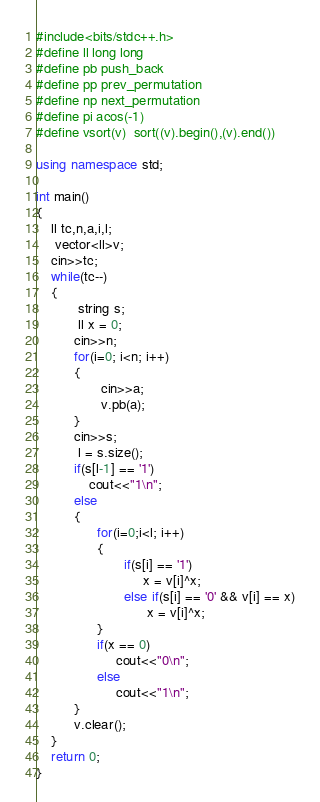Convert code to text. <code><loc_0><loc_0><loc_500><loc_500><_C++_>#include<bits/stdc++.h>
#define ll long long
#define pb push_back
#define pp prev_permutation
#define np next_permutation
#define pi acos(-1)
#define vsort(v)  sort((v).begin(),(v).end())

using namespace std;

int main()
{
    ll tc,n,a,i,l;
     vector<ll>v;
    cin>>tc;
    while(tc--)
    {
           string s;
           ll x = 0;
          cin>>n;
          for(i=0; i<n; i++)
          {
                 cin>>a;
                 v.pb(a);
          }
          cin>>s;
           l = s.size();
          if(s[l-1] == '1')
              cout<<"1\n";
          else
          {
                for(i=0;i<l; i++)
                {
                       if(s[i] == '1')
                            x = v[i]^x;
                       else if(s[i] == '0' && v[i] == x)
                             x = v[i]^x;
                }
                if(x == 0)
                     cout<<"0\n";
                else
                     cout<<"1\n";
          }
          v.clear();
    }
    return 0;
}

</code> 